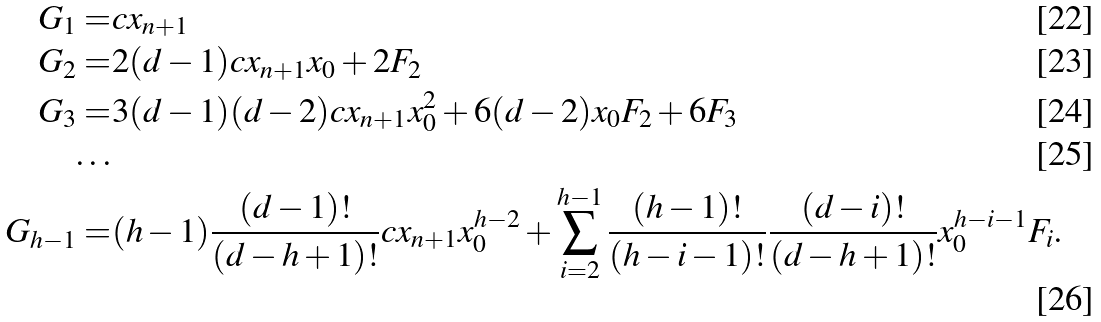Convert formula to latex. <formula><loc_0><loc_0><loc_500><loc_500>G _ { 1 } = & c x _ { n + 1 } \\ G _ { 2 } = & 2 ( d - 1 ) c x _ { n + 1 } x _ { 0 } + 2 F _ { 2 } \\ G _ { 3 } = & 3 ( d - 1 ) ( d - 2 ) c x _ { n + 1 } x ^ { 2 } _ { 0 } + 6 ( d - 2 ) x _ { 0 } F _ { 2 } + 6 F _ { 3 } \\ \dots \\ G _ { h - 1 } = & ( h - 1 ) \frac { ( d - 1 ) ! } { ( d - h + 1 ) ! } c x _ { n + 1 } x _ { 0 } ^ { h - 2 } + \sum _ { i = 2 } ^ { h - 1 } \frac { ( h - 1 ) ! } { ( h - i - 1 ) ! } \frac { ( d - i ) ! } { ( d - h + 1 ) ! } x _ { 0 } ^ { h - i - 1 } F _ { i } .</formula> 